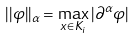Convert formula to latex. <formula><loc_0><loc_0><loc_500><loc_500>| | \varphi | | _ { \alpha } = \max _ { x \in K _ { i } } | \partial ^ { \alpha } \varphi |</formula> 